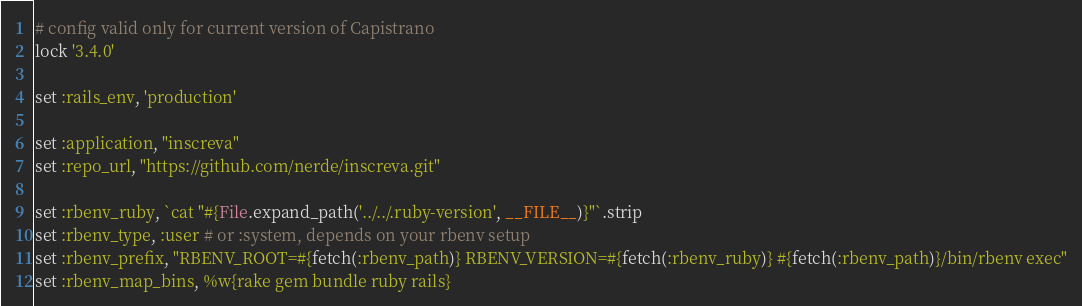Convert code to text. <code><loc_0><loc_0><loc_500><loc_500><_Ruby_># config valid only for current version of Capistrano
lock '3.4.0'

set :rails_env, 'production'

set :application, "inscreva"
set :repo_url, "https://github.com/nerde/inscreva.git"

set :rbenv_ruby, `cat "#{File.expand_path('../../.ruby-version', __FILE__)}"`.strip
set :rbenv_type, :user # or :system, depends on your rbenv setup
set :rbenv_prefix, "RBENV_ROOT=#{fetch(:rbenv_path)} RBENV_VERSION=#{fetch(:rbenv_ruby)} #{fetch(:rbenv_path)}/bin/rbenv exec"
set :rbenv_map_bins, %w{rake gem bundle ruby rails}
</code> 